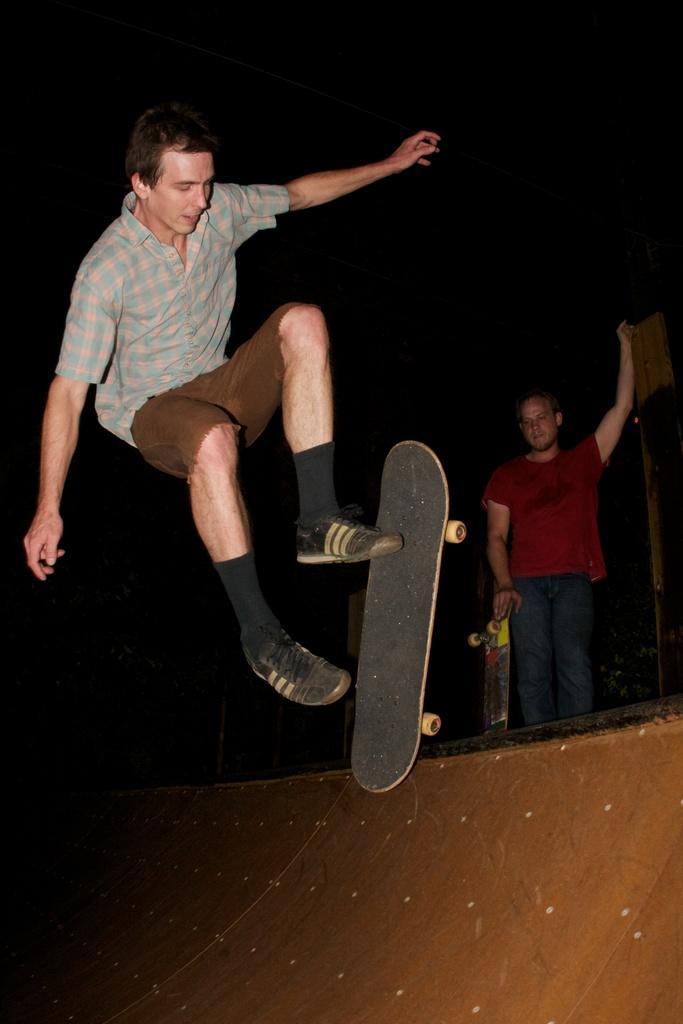Describe this image in one or two sentences. In this image, there are a few people. Among them, we can see a person holding a skateboard. We can see the ground and some poles. We can also see an object on the right. We can see the dark background. 